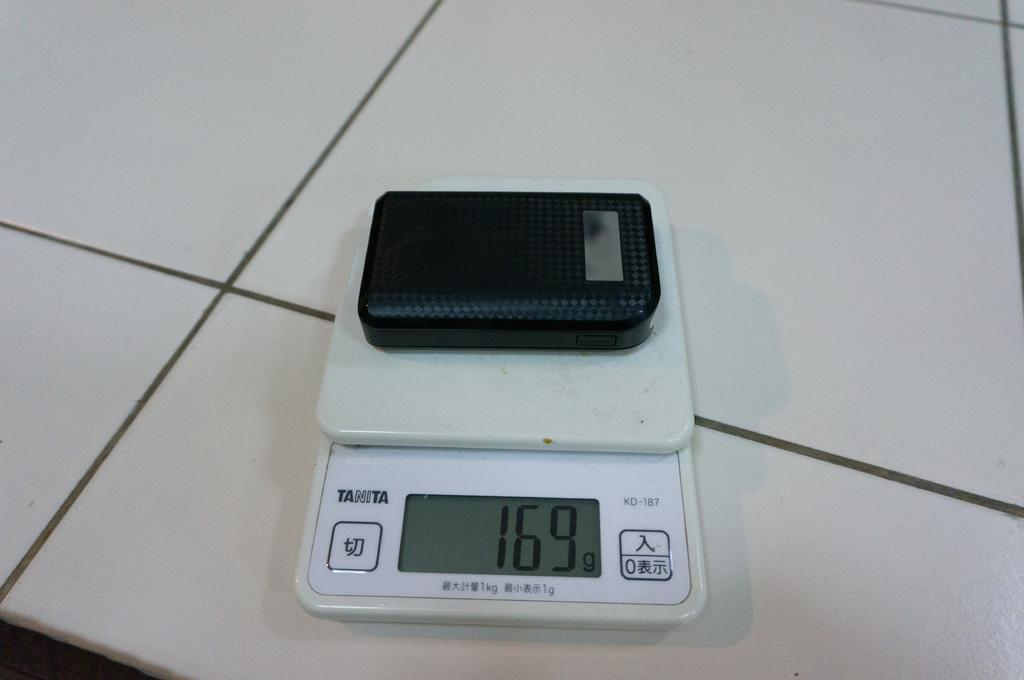Provide a one-sentence caption for the provided image. A black box is being weighed on a Tanita brand scale. 